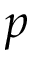<formula> <loc_0><loc_0><loc_500><loc_500>p</formula> 